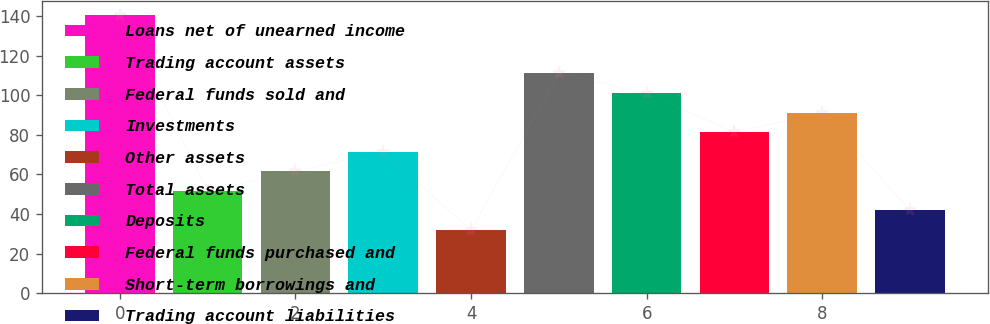Convert chart. <chart><loc_0><loc_0><loc_500><loc_500><bar_chart><fcel>Loans net of unearned income<fcel>Trading account assets<fcel>Federal funds sold and<fcel>Investments<fcel>Other assets<fcel>Total assets<fcel>Deposits<fcel>Federal funds purchased and<fcel>Short-term borrowings and<fcel>Trading account liabilities<nl><fcel>140.8<fcel>51.7<fcel>61.6<fcel>71.5<fcel>31.9<fcel>111.1<fcel>101.2<fcel>81.4<fcel>91.3<fcel>41.8<nl></chart> 